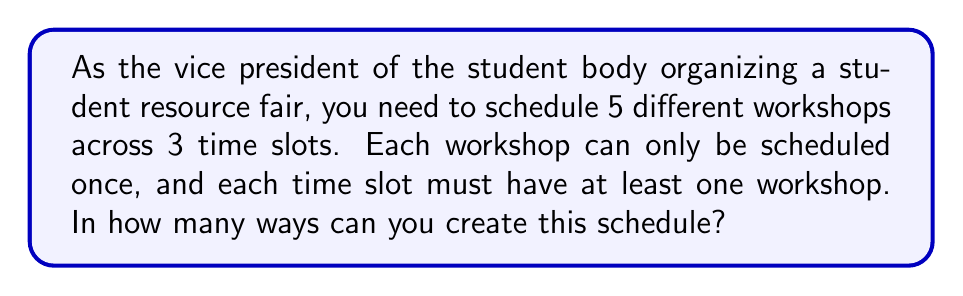Can you answer this question? Let's approach this step-by-step:

1) First, we need to distribute 5 workshops into 3 time slots. This is a partition problem.

2) The possible ways to partition 5 workshops into 3 non-empty slots are:
   3 + 1 + 1
   2 + 2 + 1

3) For the 3 + 1 + 1 partition:
   - Choose 3 workshops for the first slot: $\binom{5}{3}$ ways
   - Choose 1 workshop for the second slot from remaining 2: $\binom{2}{1}$ ways
   - The last workshop goes to the third slot: $\binom{1}{1}$ way
   - Multiply these: $\binom{5}{3} \cdot \binom{2}{1} \cdot \binom{1}{1} = 10 \cdot 2 \cdot 1 = 20$
   - But the 1+1 part can be arranged in 2! = 2 ways
   - So total for this partition: $20 \cdot 2 = 40$

4) For the 2 + 2 + 1 partition:
   - Choose 2 workshops for the first slot: $\binom{5}{2}$ ways
   - Choose 2 workshops for the second slot from remaining 3: $\binom{3}{2}$ ways
   - The last workshop goes to the third slot: $\binom{1}{1}$ way
   - Multiply these: $\binom{5}{2} \cdot \binom{3}{2} \cdot \binom{1}{1} = 10 \cdot 3 \cdot 1 = 30$
   - The 2+2+1 can be arranged in 3! = 6 ways
   - So total for this partition: $30 \cdot 6 = 180$

5) Sum up all possibilities: 40 + 180 = 220
Answer: 220 